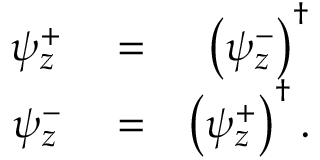<formula> <loc_0><loc_0><loc_500><loc_500>\begin{array} { r l r } { \psi _ { z } ^ { + } } & = } & { \left ( \psi _ { z } ^ { - } \right ) ^ { \dagger } } \\ { \psi _ { z } ^ { - } } & = } & { \left ( \psi _ { z } ^ { + } \right ) ^ { \dagger } . } \end{array}</formula> 